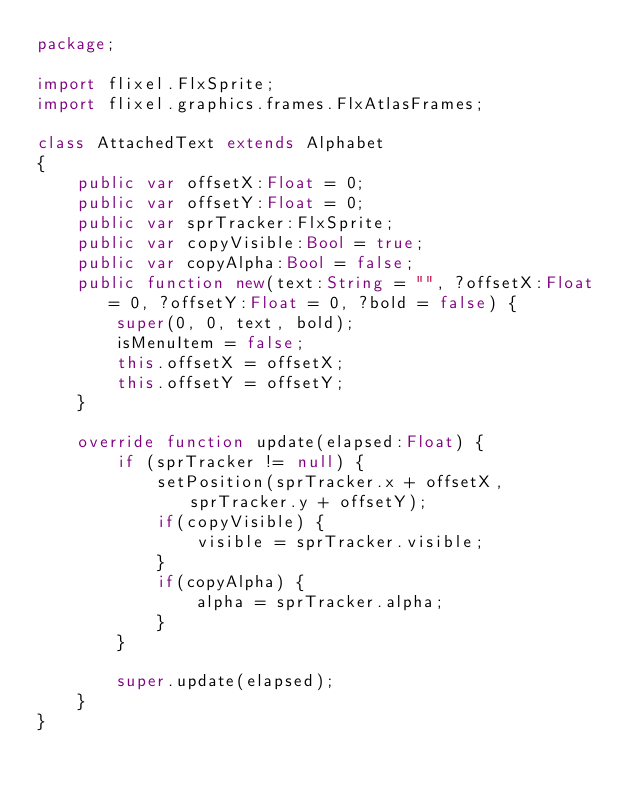<code> <loc_0><loc_0><loc_500><loc_500><_Haxe_>package;

import flixel.FlxSprite;
import flixel.graphics.frames.FlxAtlasFrames;

class AttachedText extends Alphabet
{
	public var offsetX:Float = 0;
	public var offsetY:Float = 0;
	public var sprTracker:FlxSprite;
	public var copyVisible:Bool = true;
	public var copyAlpha:Bool = false;
	public function new(text:String = "", ?offsetX:Float = 0, ?offsetY:Float = 0, ?bold = false) {
		super(0, 0, text, bold);
		isMenuItem = false;
		this.offsetX = offsetX;
		this.offsetY = offsetY;
	}

	override function update(elapsed:Float) {
		if (sprTracker != null) {
			setPosition(sprTracker.x + offsetX, sprTracker.y + offsetY);
			if(copyVisible) {
				visible = sprTracker.visible;
			}
			if(copyAlpha) {
				alpha = sprTracker.alpha;
			}
		}

		super.update(elapsed);
	}
}</code> 